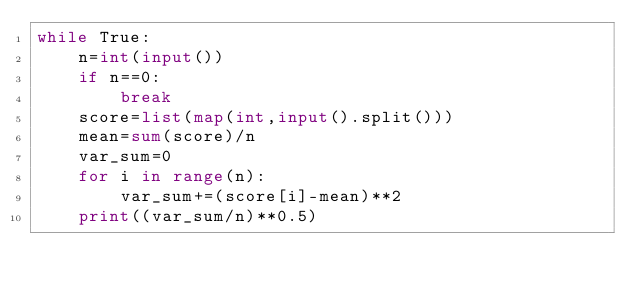Convert code to text. <code><loc_0><loc_0><loc_500><loc_500><_Python_>while True:
    n=int(input())
    if n==0:
        break
    score=list(map(int,input().split()))
    mean=sum(score)/n
    var_sum=0
    for i in range(n):
        var_sum+=(score[i]-mean)**2
    print((var_sum/n)**0.5)
</code> 